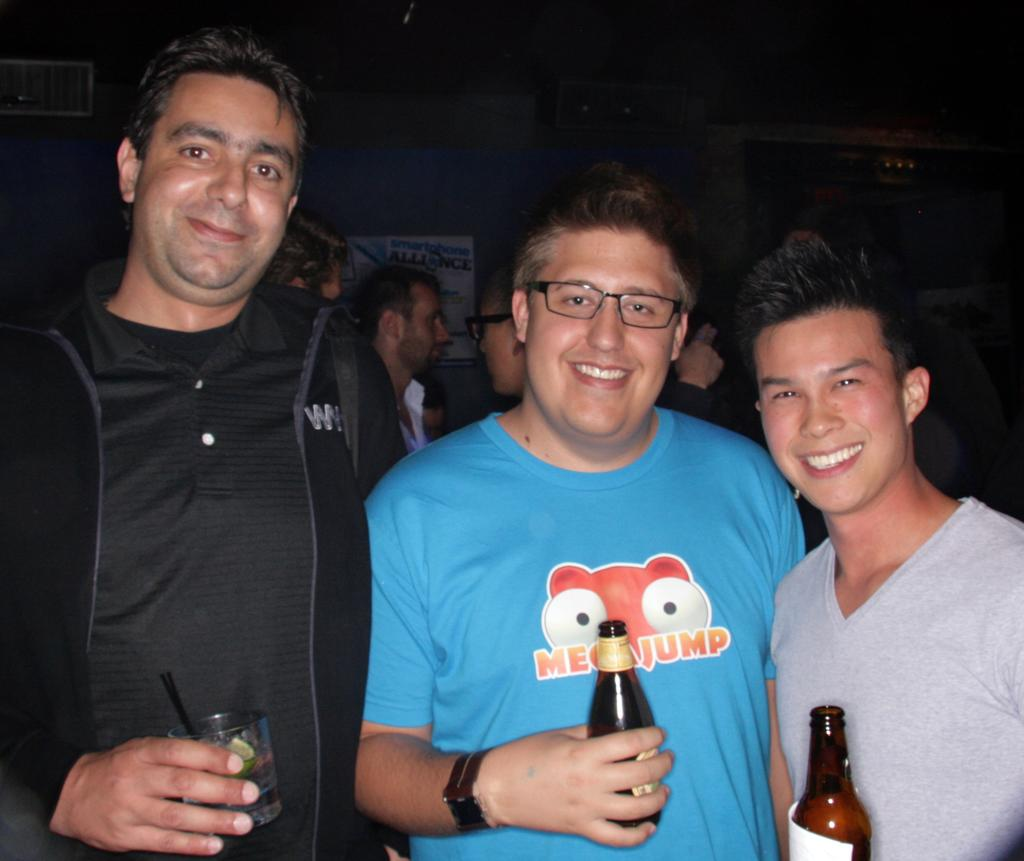How many people are in the image? There are three men in the image. What are the men doing in the image? The men are standing in the image. What objects are the men holding in their hands? The men are holding bottles in their hands, and one man is holding a glass. What type of quiver can be seen on the back of one of the men in the image? There is no quiver present on the back of any of the men in the image. What type of seed is being held by one of the men in the image? There is no seed being held by any of the men in the image. 